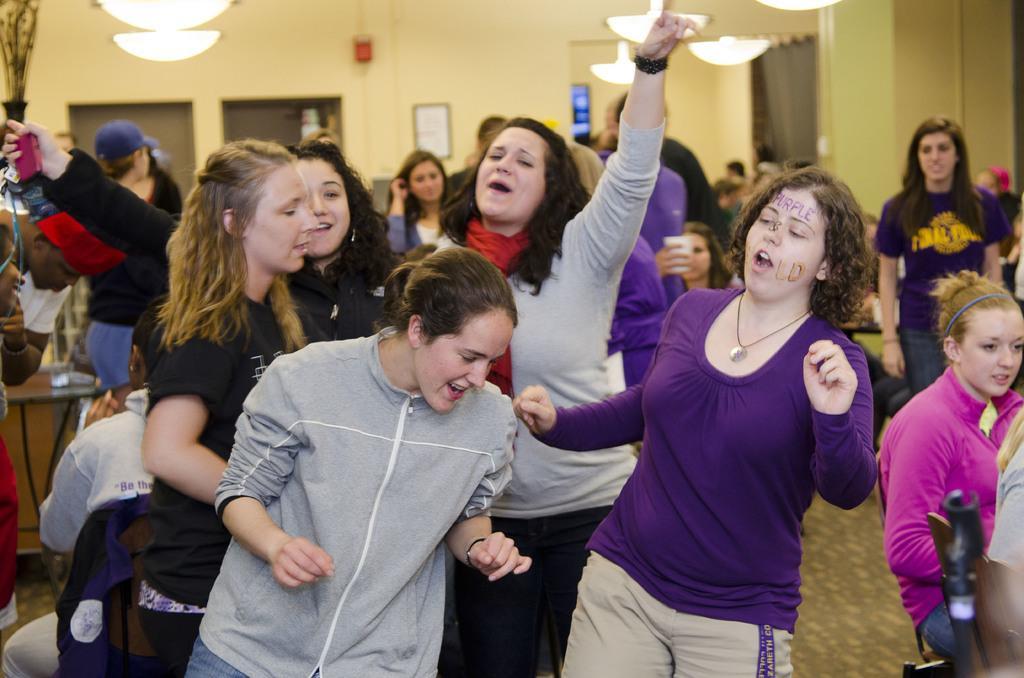Can you describe this image briefly? In this picture, we can see a group of people some are standing on the floor and some people are sitting on chairs and behind the people there is a wall with a photo frame and other items and there are ceiling lights on the top. 